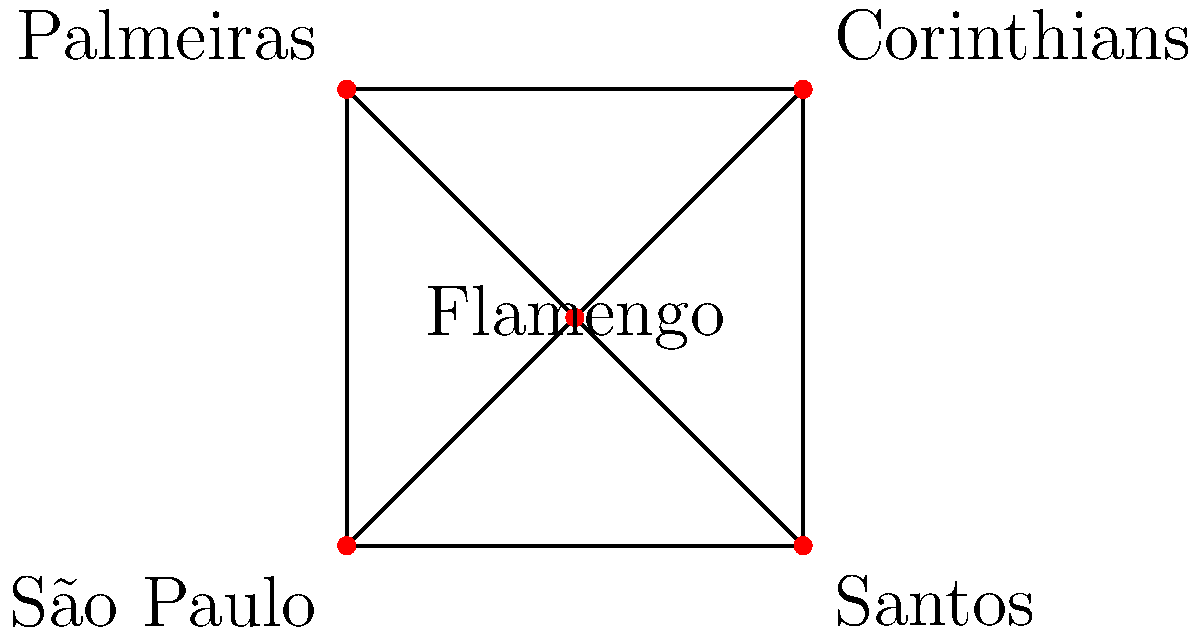In the graph above, each vertex represents a famous Brazilian football team, and each edge represents a match that needs to be scheduled. What is the minimum number of time slots needed to schedule all matches without conflicts, assuming that no team can play more than one match in the same time slot? To solve this problem, we need to use the concept of graph coloring. Here's a step-by-step explanation:

1. The graph shown is a complete graph with 5 vertices (K5), as each team needs to play against every other team.

2. In graph coloring, each color represents a time slot. No two adjacent vertices (connected by an edge) can have the same color, as this would mean two teams playing each other in the same time slot.

3. The minimum number of colors needed to color a graph is called the chromatic number of the graph.

4. For a complete graph with n vertices (Kn), the chromatic number is always equal to n.

5. In this case, we have K5, so the chromatic number is 5.

6. This means we need at least 5 different colors to color the graph, which translates to 5 different time slots to schedule all matches without conflicts.

Therefore, the minimum number of time slots needed is 5.
Answer: 5 time slots 